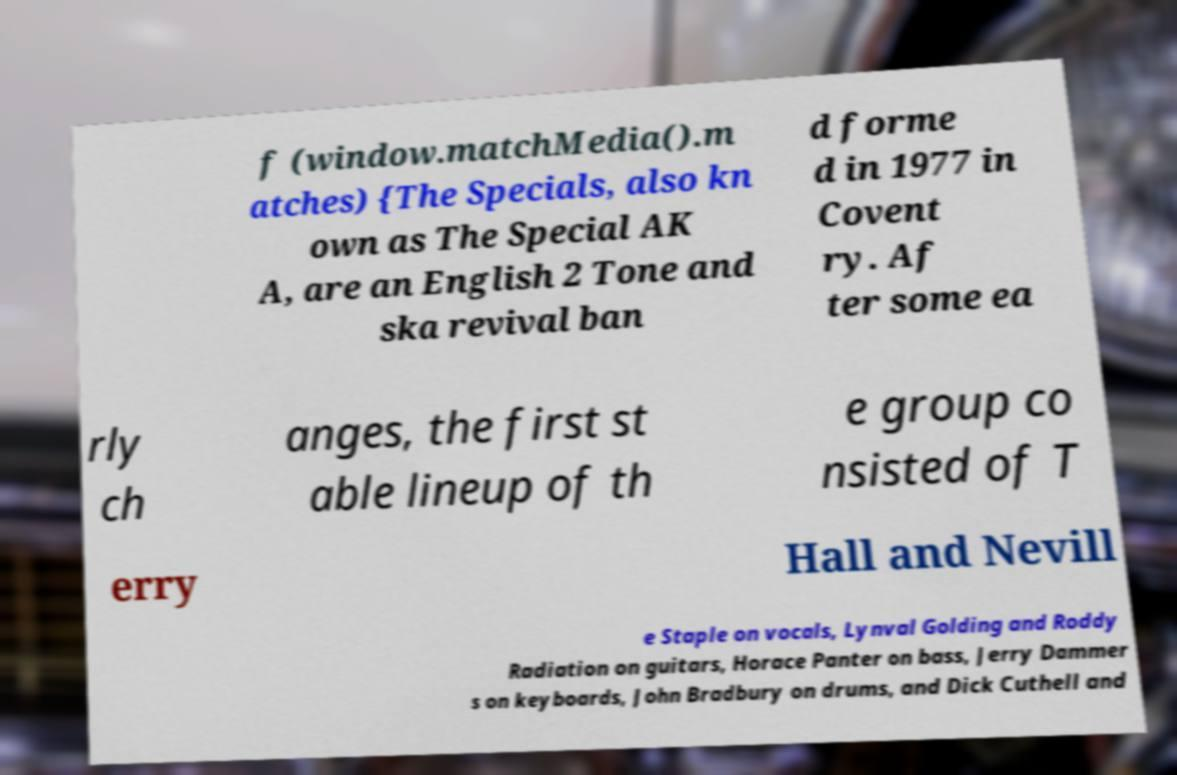There's text embedded in this image that I need extracted. Can you transcribe it verbatim? f (window.matchMedia().m atches) {The Specials, also kn own as The Special AK A, are an English 2 Tone and ska revival ban d forme d in 1977 in Covent ry. Af ter some ea rly ch anges, the first st able lineup of th e group co nsisted of T erry Hall and Nevill e Staple on vocals, Lynval Golding and Roddy Radiation on guitars, Horace Panter on bass, Jerry Dammer s on keyboards, John Bradbury on drums, and Dick Cuthell and 